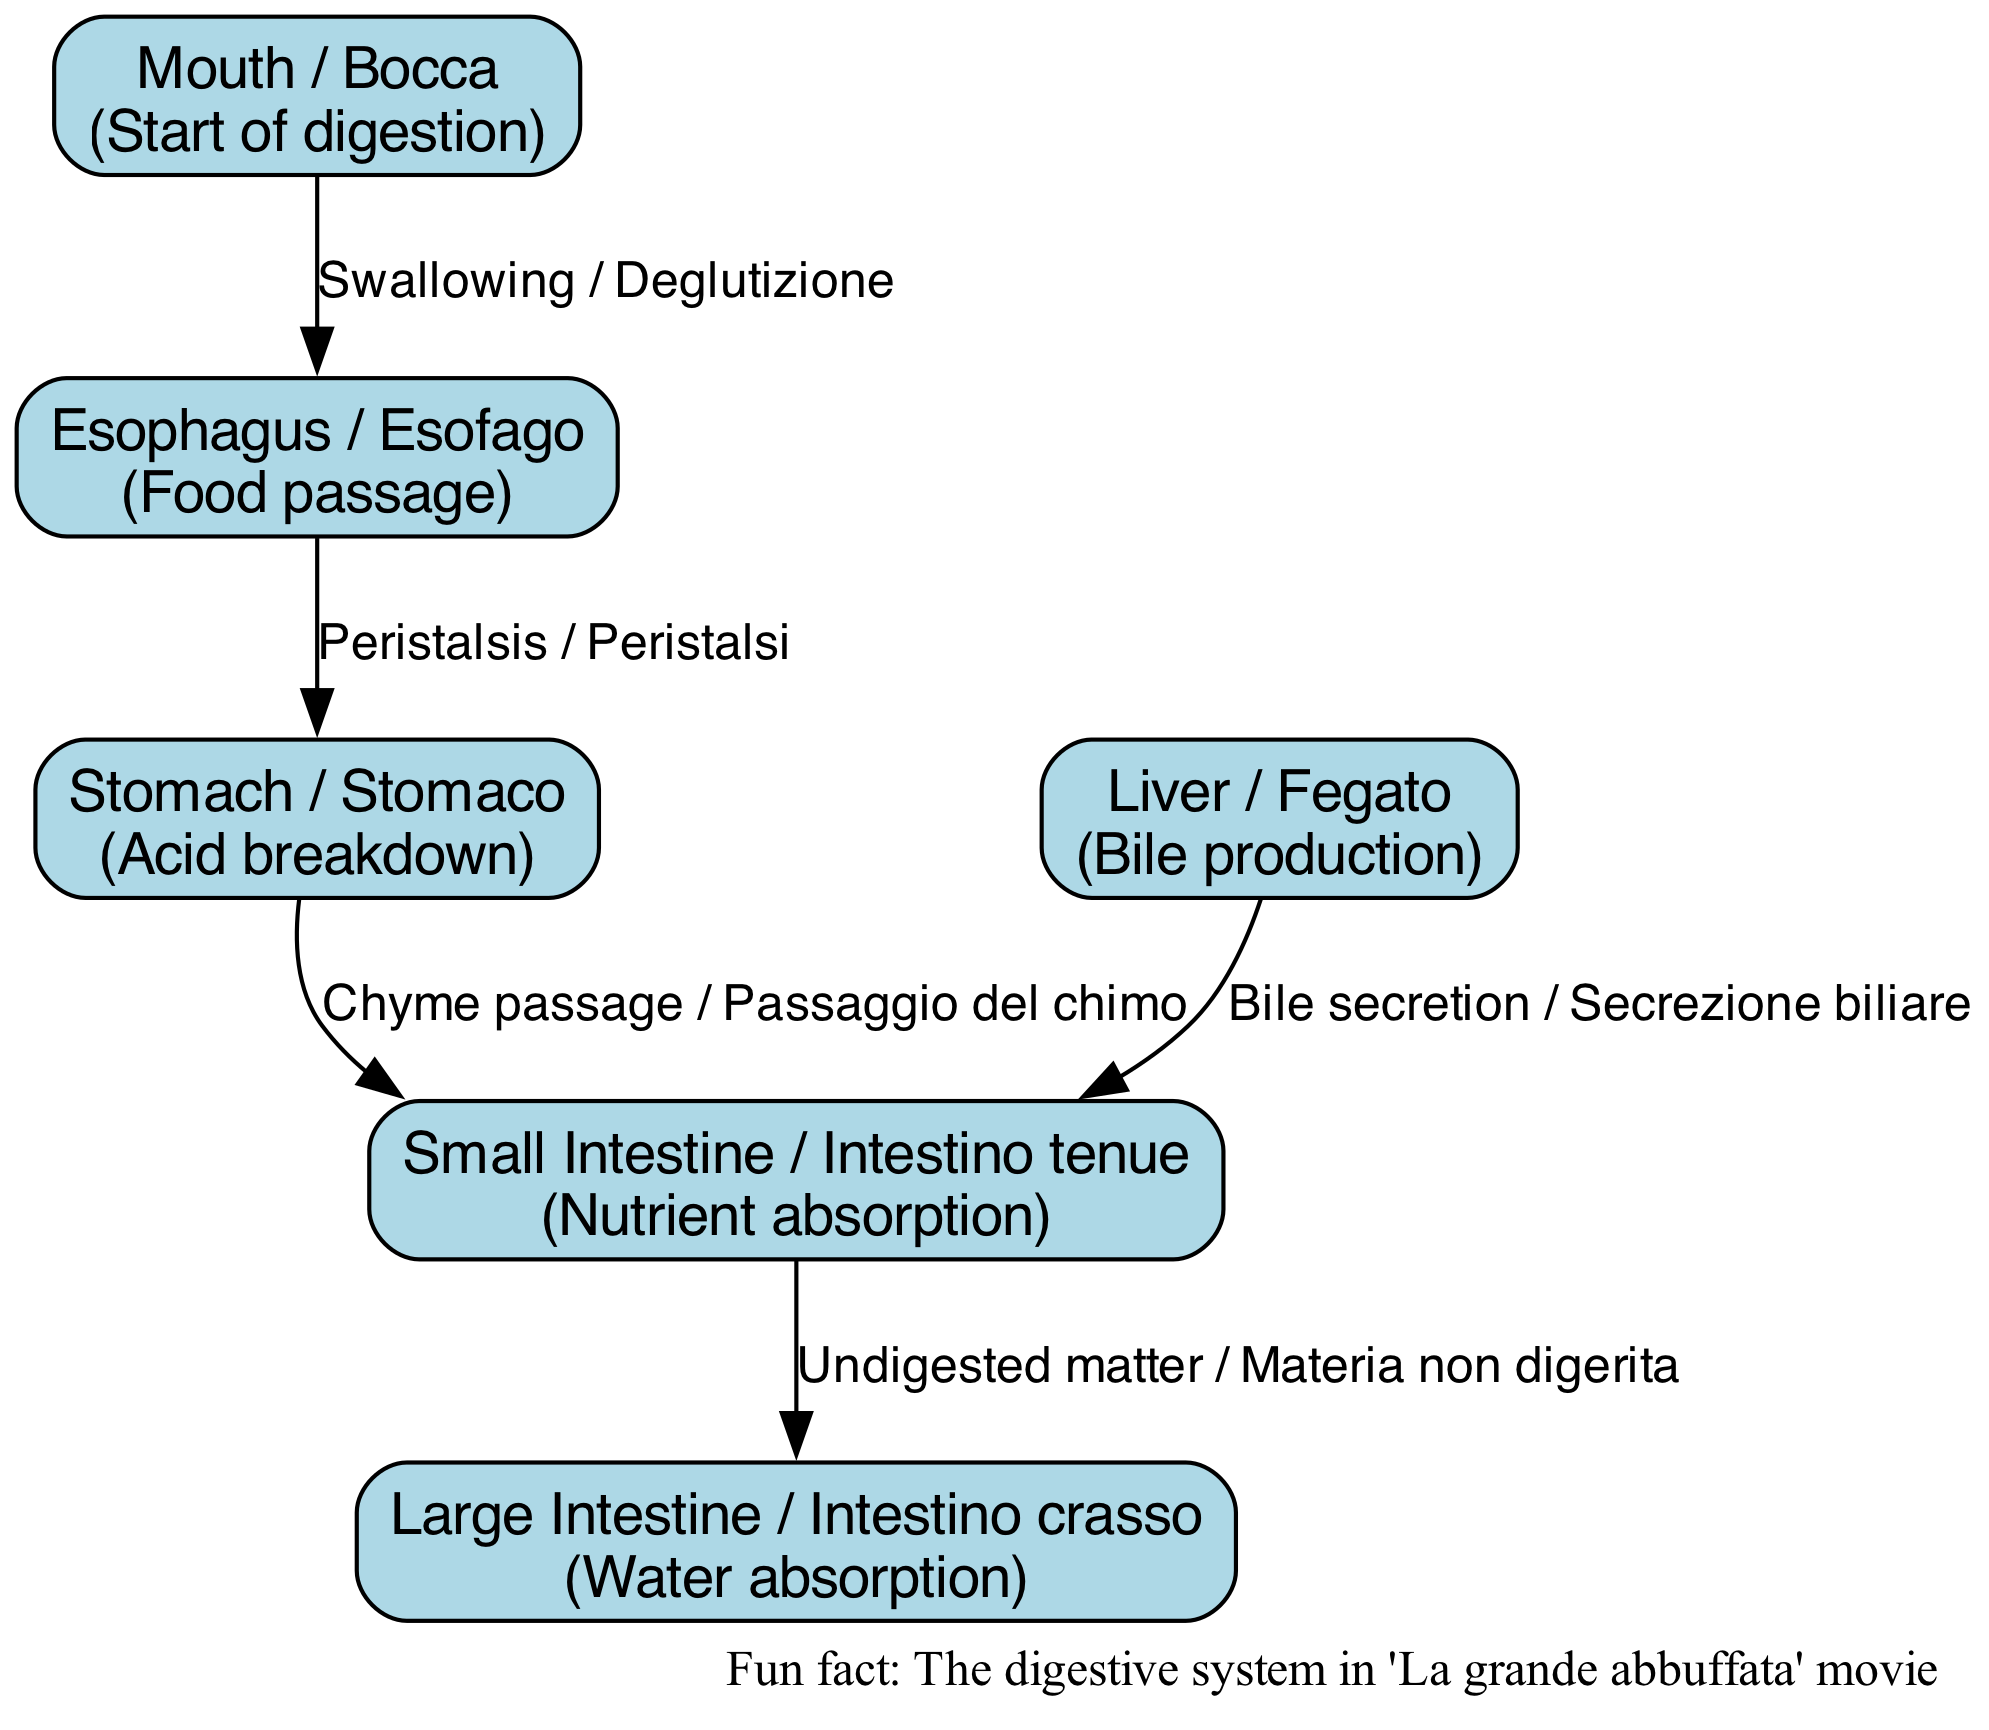What is the starting point of digestion? The diagram indicates that digestion begins at the "Mouth / Bocca". This is specifically labeled in the diagram as the first major organ involved in the digestive process.
Answer: Mouth / Bocca What is produced by the liver? According to the diagram, the liver is labeled with the description "Bile production", which specifically states its function.
Answer: Bile How many major organs are illustrated in the diagram? By counting the nodes listed in the diagram, there are six major organs depicted: mouth, esophagus, stomach, small intestine, large intestine, and liver. This is a straightforward count of the nodes representing major components of the digestive system.
Answer: 6 What process occurs between the mouth and the esophagus? The diagram describes the relationship between the mouth and the esophagus with the label "Swallowing / Deglutizione". This indicates what action takes place to transfer food from one section to the other.
Answer: Swallowing / Deglutizione What is the role of the small intestine in digestion? The diagram states that the small intestine is responsible for "Nutrient absorption", conveying its primary function in the digestive system. This is highlighted clearly in the description associated with the small intestine.
Answer: Nutrient absorption What kind of matter passes from the small intestine to the large intestine? The relationship labeled between the small intestine and large intestine indicates "Undigested matter / Materia non digerita", specifying what type of matter is transferred at this stage of digestion.
Answer: Undigested matter / Materia non digerita What action facilitates food movement from the esophagus to the stomach? The directed edge in the diagram explains that "Peristalsis / Peristalsi" is the action that moves food from the esophagus to the stomach. This term specifically refers to the wave-like muscle contractions involved in digestion.
Answer: Peristalsis / Peristalsi Which organ secretes bile into the small intestine? The diagram clearly shows that the liver is the source of bile, which is indicated by the labeled edge "Bile secretion / Secrezione biliare" connecting the liver to the small intestine. This explains the flow of bile produced by the liver into the digestive tract.
Answer: Liver / Fegato What is absorbed by the large intestine? The diagram states that the large intestine is responsible for "Water absorption", detailing its role in the digestive system after nutrients have been absorbed in the small intestine.
Answer: Water absorption 